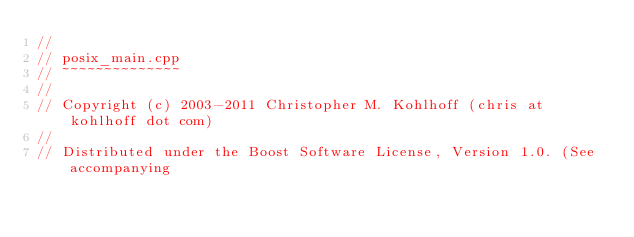Convert code to text. <code><loc_0><loc_0><loc_500><loc_500><_C++_>//
// posix_main.cpp
// ~~~~~~~~~~~~~~
//
// Copyright (c) 2003-2011 Christopher M. Kohlhoff (chris at kohlhoff dot com)
//
// Distributed under the Boost Software License, Version 1.0. (See accompanying</code> 